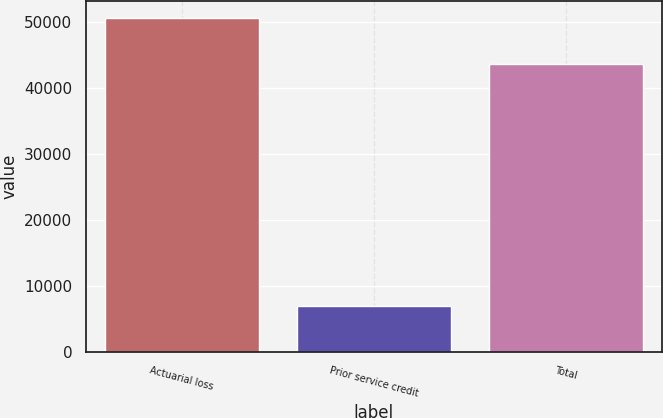<chart> <loc_0><loc_0><loc_500><loc_500><bar_chart><fcel>Actuarial loss<fcel>Prior service credit<fcel>Total<nl><fcel>50543<fcel>6956<fcel>43587<nl></chart> 